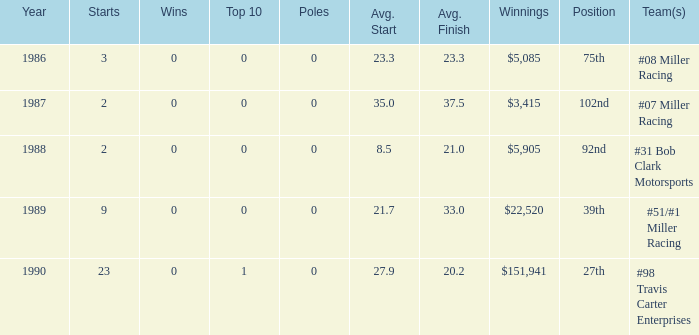Which racing teams have a mean finish of 2 #08 Miller Racing. 